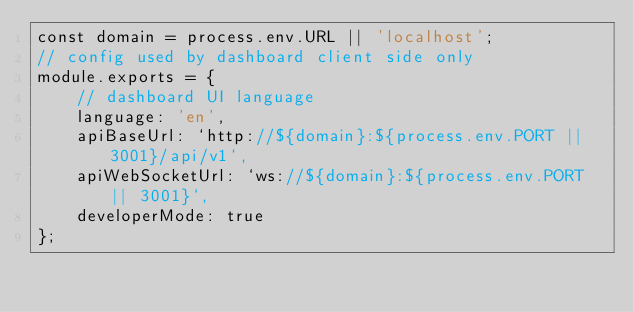Convert code to text. <code><loc_0><loc_0><loc_500><loc_500><_JavaScript_>const domain = process.env.URL || 'localhost';
// config used by dashboard client side only
module.exports = {
	// dashboard UI language
	language: 'en',
	apiBaseUrl: `http://${domain}:${process.env.PORT || 3001}/api/v1`,
	apiWebSocketUrl: `ws://${domain}:${process.env.PORT || 3001}`,
	developerMode: true
};
</code> 